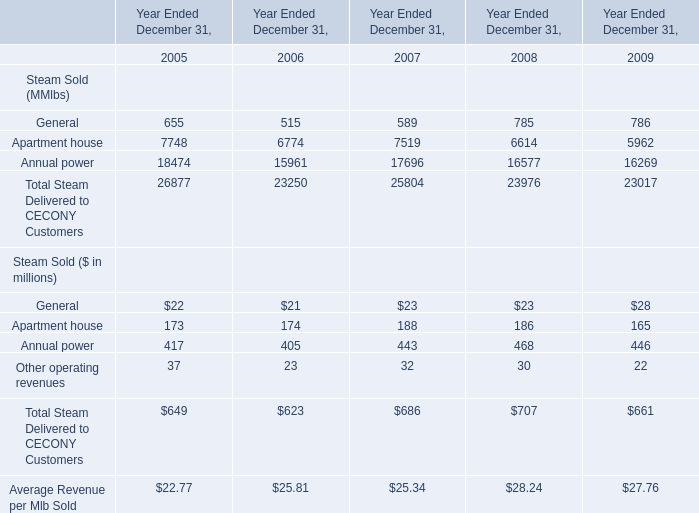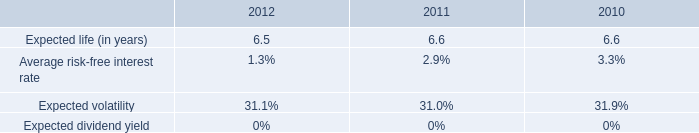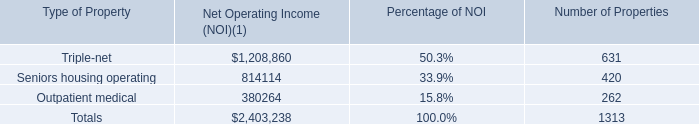How many years does Annual power stay higher than Apartment house? 
Answer: 5. 